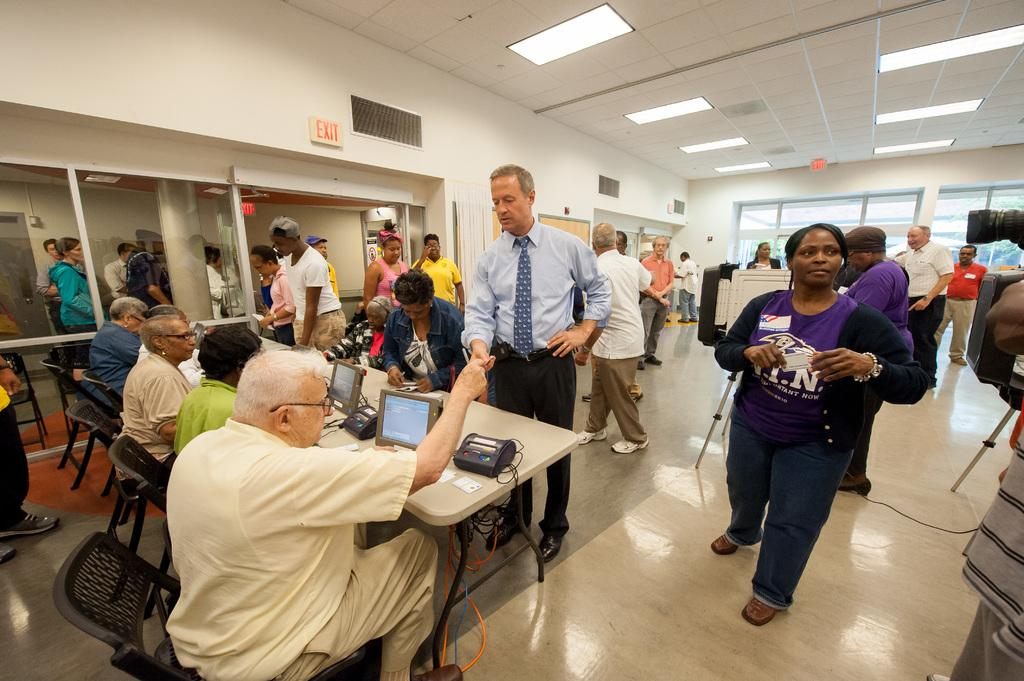<image>
Give a short and clear explanation of the subsequent image. An exit sign hangs over the doorway of a room in which people work on computers and at whiteboards. 